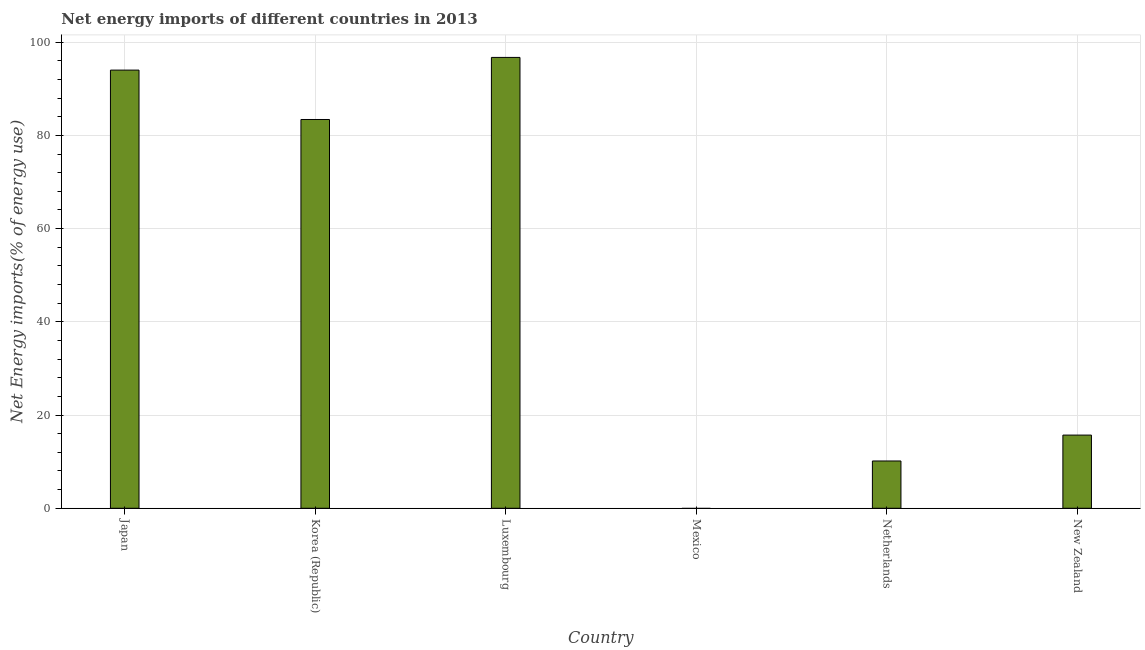Does the graph contain any zero values?
Offer a terse response. Yes. Does the graph contain grids?
Give a very brief answer. Yes. What is the title of the graph?
Keep it short and to the point. Net energy imports of different countries in 2013. What is the label or title of the X-axis?
Offer a terse response. Country. What is the label or title of the Y-axis?
Give a very brief answer. Net Energy imports(% of energy use). What is the energy imports in Korea (Republic)?
Your answer should be compact. 83.4. Across all countries, what is the maximum energy imports?
Give a very brief answer. 96.72. Across all countries, what is the minimum energy imports?
Your answer should be very brief. 0. In which country was the energy imports maximum?
Offer a very short reply. Luxembourg. What is the sum of the energy imports?
Your response must be concise. 299.97. What is the difference between the energy imports in Luxembourg and Netherlands?
Your response must be concise. 86.58. What is the average energy imports per country?
Ensure brevity in your answer.  49.99. What is the median energy imports?
Give a very brief answer. 49.55. What is the ratio of the energy imports in Japan to that in Netherlands?
Keep it short and to the point. 9.27. Is the energy imports in Korea (Republic) less than that in Luxembourg?
Ensure brevity in your answer.  Yes. Is the difference between the energy imports in Japan and Netherlands greater than the difference between any two countries?
Make the answer very short. No. What is the difference between the highest and the second highest energy imports?
Keep it short and to the point. 2.72. What is the difference between the highest and the lowest energy imports?
Provide a short and direct response. 96.72. How many bars are there?
Ensure brevity in your answer.  5. Are all the bars in the graph horizontal?
Provide a short and direct response. No. How many countries are there in the graph?
Make the answer very short. 6. What is the Net Energy imports(% of energy use) of Japan?
Make the answer very short. 94. What is the Net Energy imports(% of energy use) of Korea (Republic)?
Offer a terse response. 83.4. What is the Net Energy imports(% of energy use) in Luxembourg?
Your answer should be very brief. 96.72. What is the Net Energy imports(% of energy use) in Netherlands?
Provide a succinct answer. 10.14. What is the Net Energy imports(% of energy use) of New Zealand?
Provide a succinct answer. 15.7. What is the difference between the Net Energy imports(% of energy use) in Japan and Korea (Republic)?
Your answer should be compact. 10.59. What is the difference between the Net Energy imports(% of energy use) in Japan and Luxembourg?
Ensure brevity in your answer.  -2.72. What is the difference between the Net Energy imports(% of energy use) in Japan and Netherlands?
Provide a short and direct response. 83.85. What is the difference between the Net Energy imports(% of energy use) in Japan and New Zealand?
Your answer should be compact. 78.3. What is the difference between the Net Energy imports(% of energy use) in Korea (Republic) and Luxembourg?
Your answer should be compact. -13.32. What is the difference between the Net Energy imports(% of energy use) in Korea (Republic) and Netherlands?
Ensure brevity in your answer.  73.26. What is the difference between the Net Energy imports(% of energy use) in Korea (Republic) and New Zealand?
Give a very brief answer. 67.7. What is the difference between the Net Energy imports(% of energy use) in Luxembourg and Netherlands?
Keep it short and to the point. 86.58. What is the difference between the Net Energy imports(% of energy use) in Luxembourg and New Zealand?
Ensure brevity in your answer.  81.02. What is the difference between the Net Energy imports(% of energy use) in Netherlands and New Zealand?
Keep it short and to the point. -5.56. What is the ratio of the Net Energy imports(% of energy use) in Japan to that in Korea (Republic)?
Make the answer very short. 1.13. What is the ratio of the Net Energy imports(% of energy use) in Japan to that in Netherlands?
Your response must be concise. 9.27. What is the ratio of the Net Energy imports(% of energy use) in Japan to that in New Zealand?
Your answer should be very brief. 5.99. What is the ratio of the Net Energy imports(% of energy use) in Korea (Republic) to that in Luxembourg?
Your answer should be very brief. 0.86. What is the ratio of the Net Energy imports(% of energy use) in Korea (Republic) to that in Netherlands?
Your answer should be compact. 8.22. What is the ratio of the Net Energy imports(% of energy use) in Korea (Republic) to that in New Zealand?
Keep it short and to the point. 5.31. What is the ratio of the Net Energy imports(% of energy use) in Luxembourg to that in Netherlands?
Your response must be concise. 9.53. What is the ratio of the Net Energy imports(% of energy use) in Luxembourg to that in New Zealand?
Keep it short and to the point. 6.16. What is the ratio of the Net Energy imports(% of energy use) in Netherlands to that in New Zealand?
Your response must be concise. 0.65. 